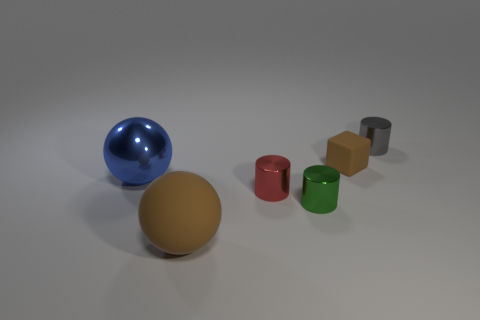Can you describe the lighting in the scene? The scene is softly lit from above, producing gentle shadows beneath the objects. The matte surface of the larger sphere diffuses the light, while the smaller blue sphere reflects light, highlighting its glossy texture. 